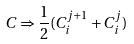Convert formula to latex. <formula><loc_0><loc_0><loc_500><loc_500>C \Rightarrow \frac { 1 } { 2 } ( C _ { i } ^ { j + 1 } + C _ { i } ^ { j } )</formula> 